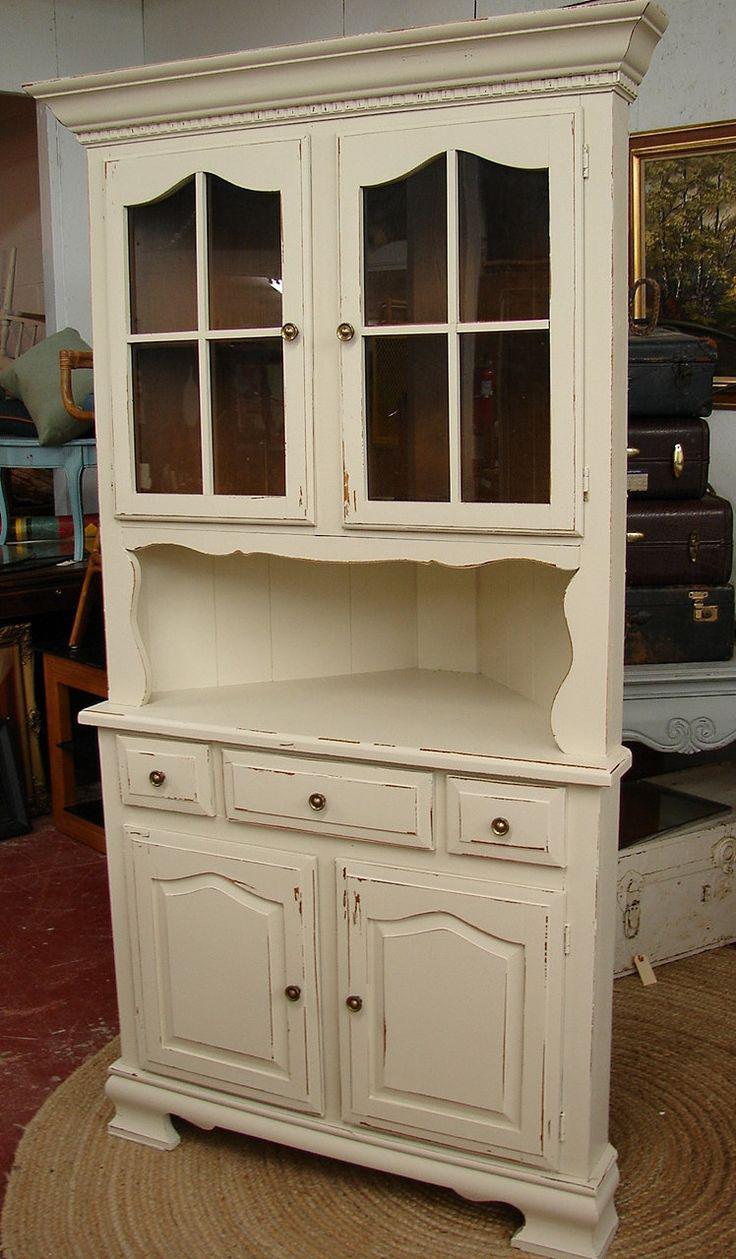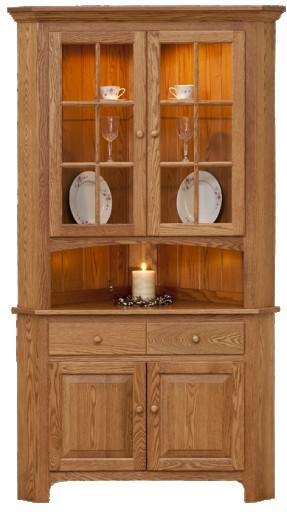The first image is the image on the left, the second image is the image on the right. For the images shown, is this caption "At least two round plates are clearly visible in the image on the right." true? Answer yes or no. Yes. 